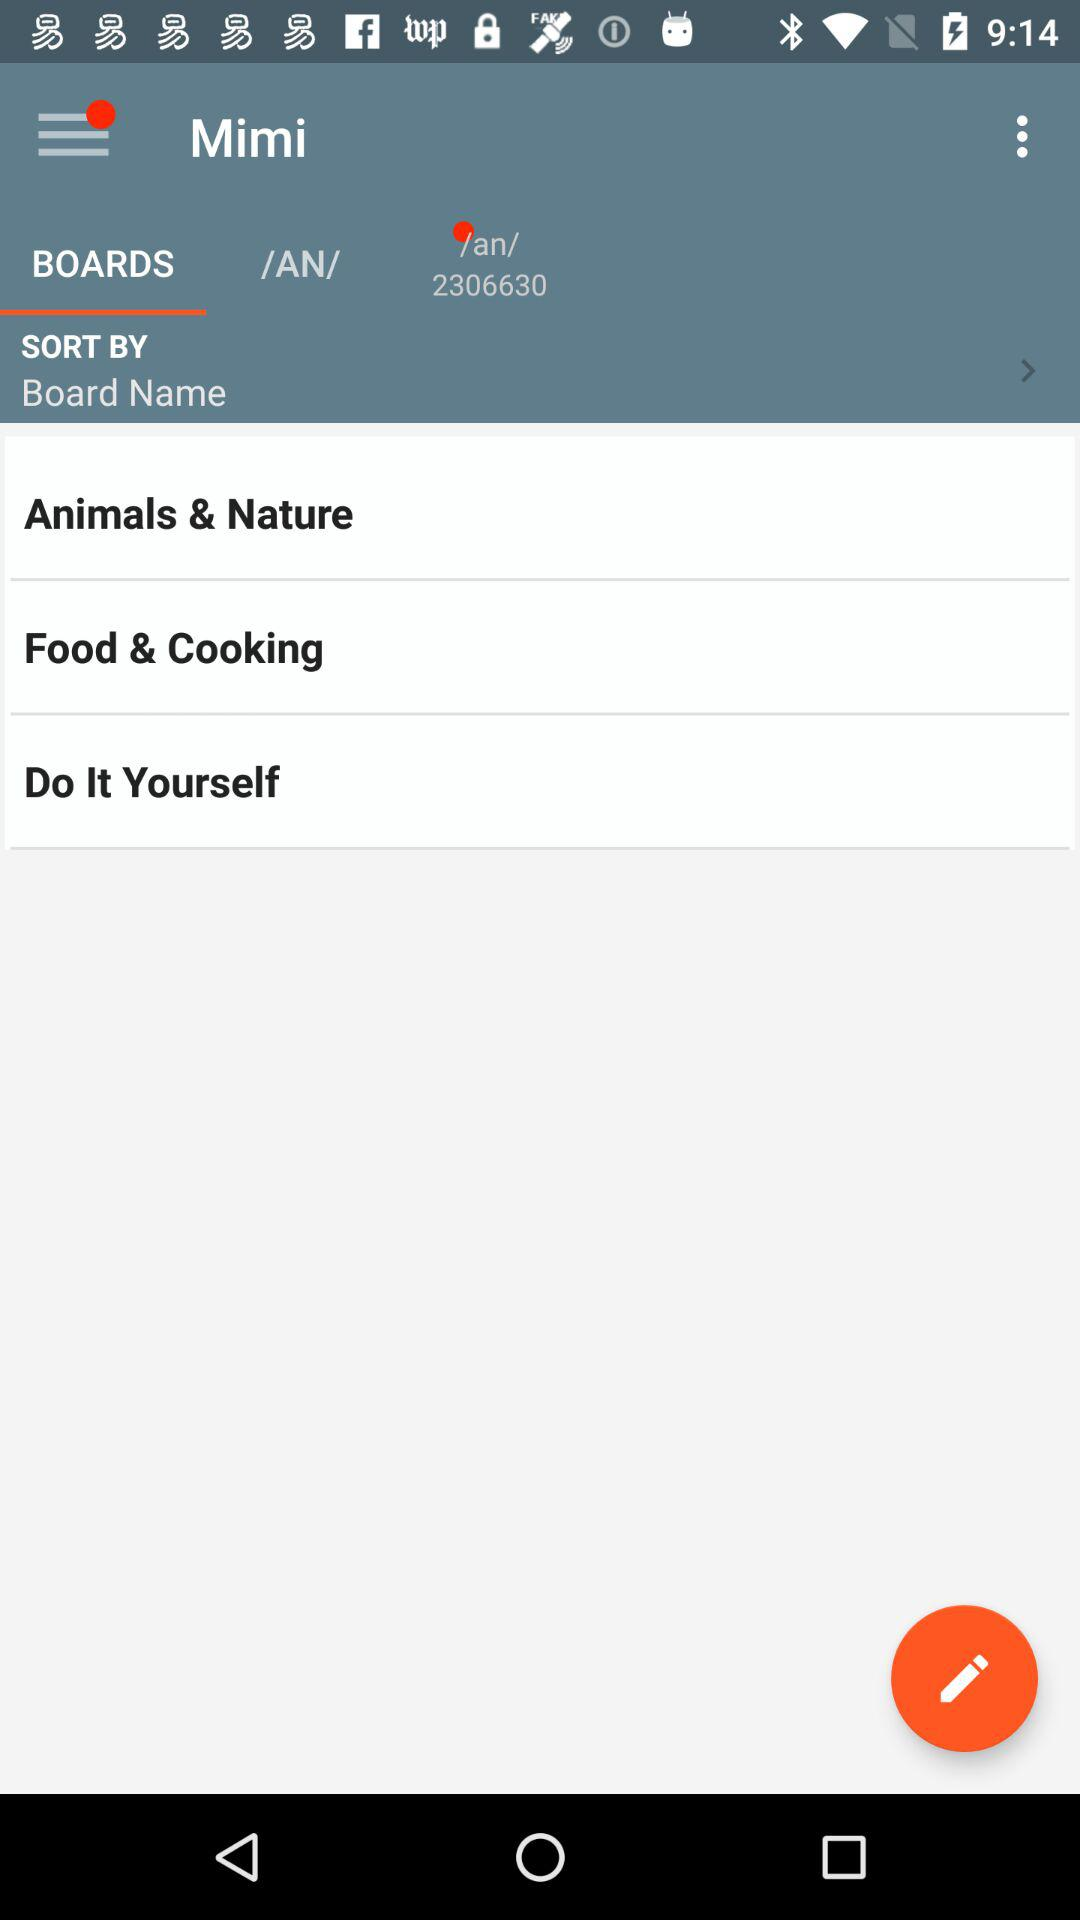Which option is selected for "Mimi"? The selected option is "BOARDS". 